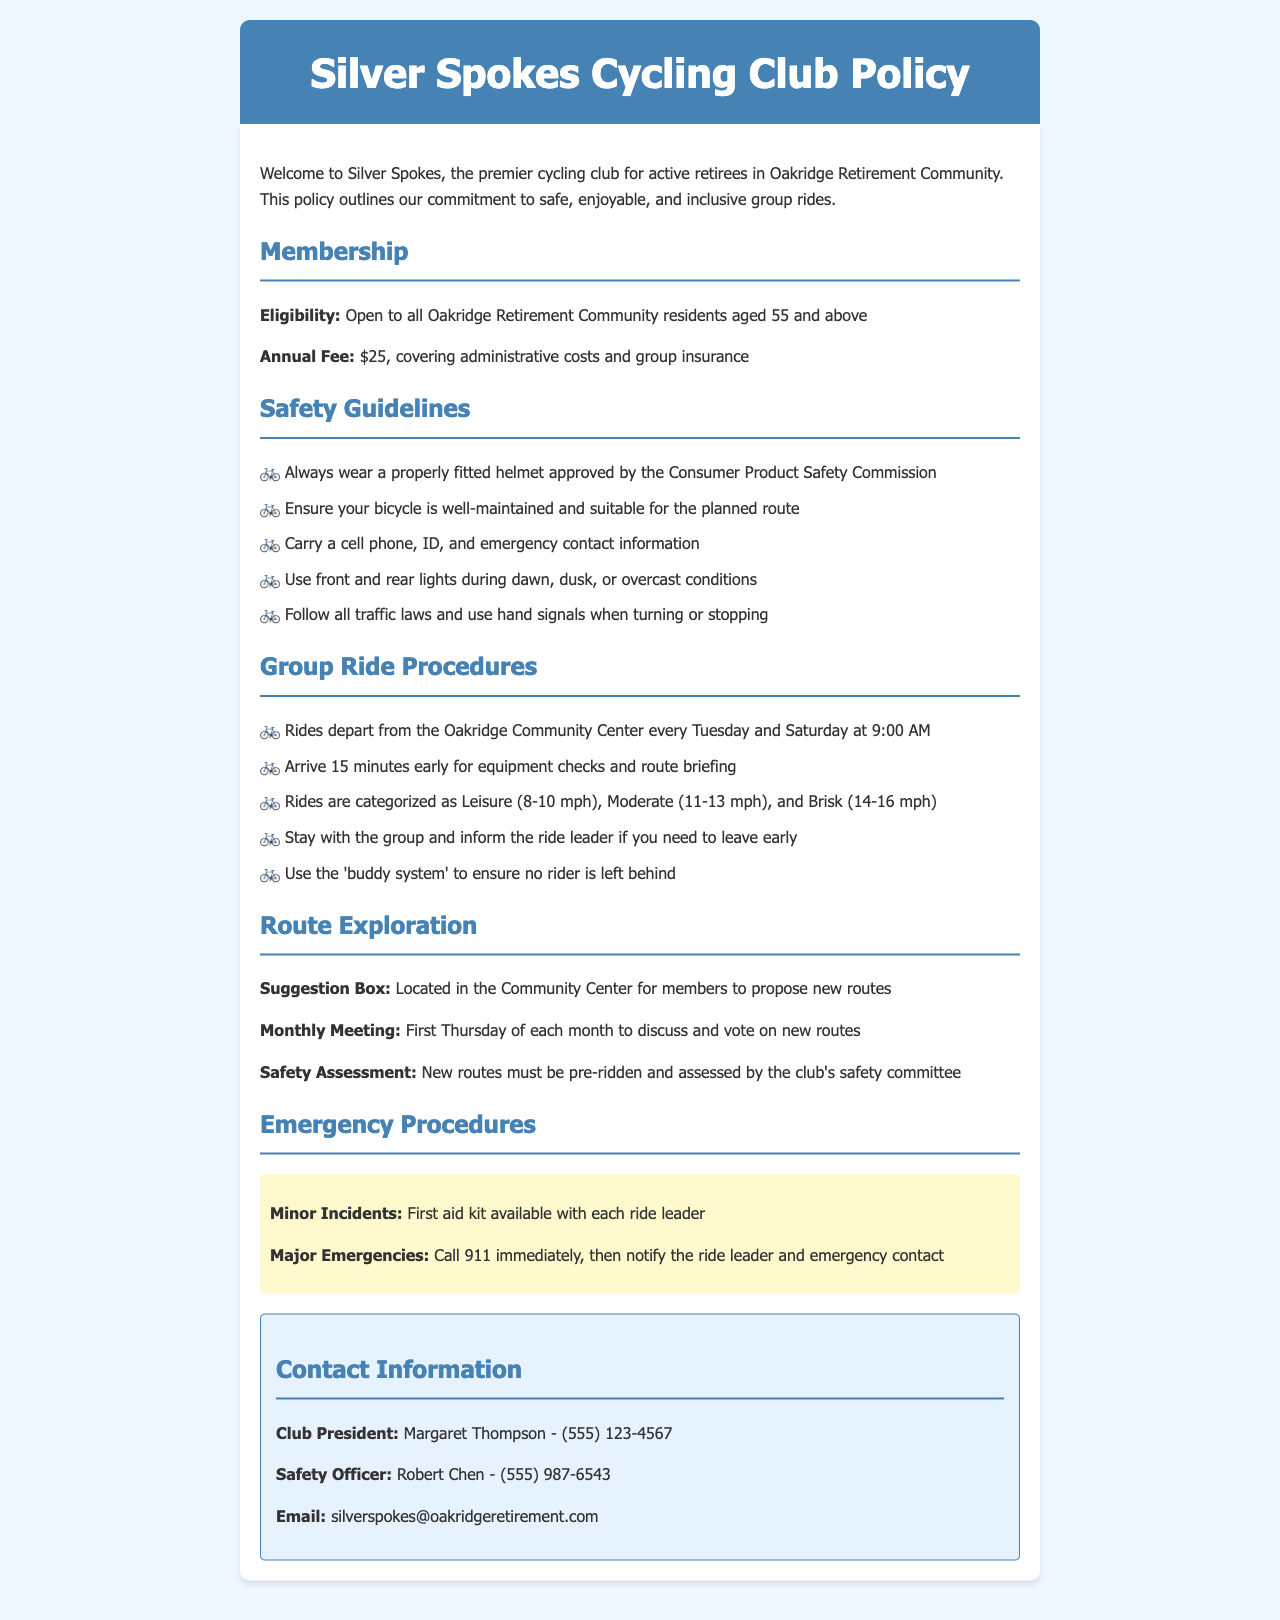What is the annual fee for membership? The annual fee is stated in the membership section of the document as $25.
Answer: $25 What are the ride categories? The ride categories are specified under the group ride procedures, which are Leisure, Moderate, and Brisk.
Answer: Leisure, Moderate, Brisk Who is the Club President? The Club President's name is mentioned in the contact information section as Margaret Thompson.
Answer: Margaret Thompson What time do rides depart? The document specifies that rides depart at 9:00 AM from the Oakridge Community Center.
Answer: 9:00 AM What should you carry during rides? The safety guidelines state that members should carry a cell phone, ID, and emergency contact information.
Answer: Cell phone, ID, emergency contact information How often are the monthly meetings held? The document states that monthly meetings are held on the first Thursday of each month.
Answer: First Thursday of each month What must new routes undergo before being approved? The safety assessment section specifies that new routes must be pre-ridden and assessed by the club's safety committee.
Answer: Pre-ridden and assessed What is the purpose of the suggestion box? The suggestion box allows members to propose new routes, as described in the route exploration section.
Answer: Propose new routes What should be done in a major emergency? The emergency procedures indicate that in a major emergency, one should call 911 immediately.
Answer: Call 911 immediately 